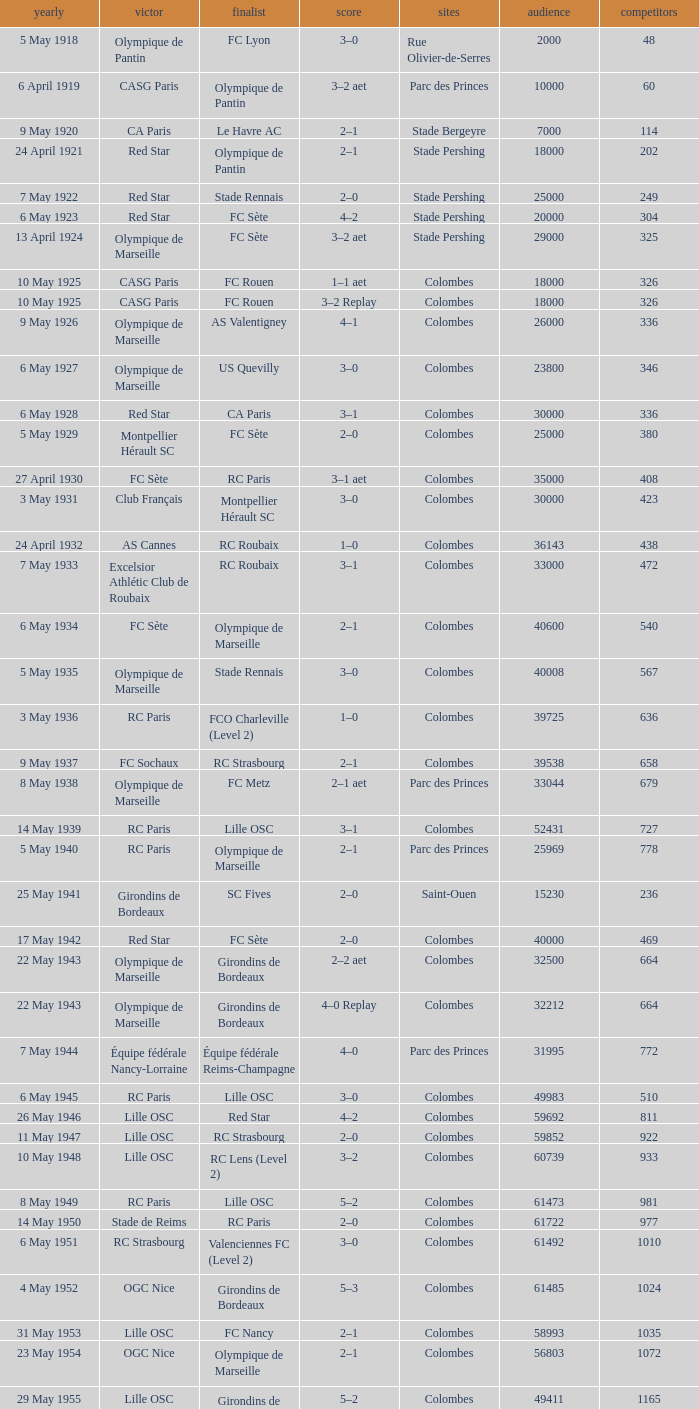How many games had red star as the runner up? 1.0. 